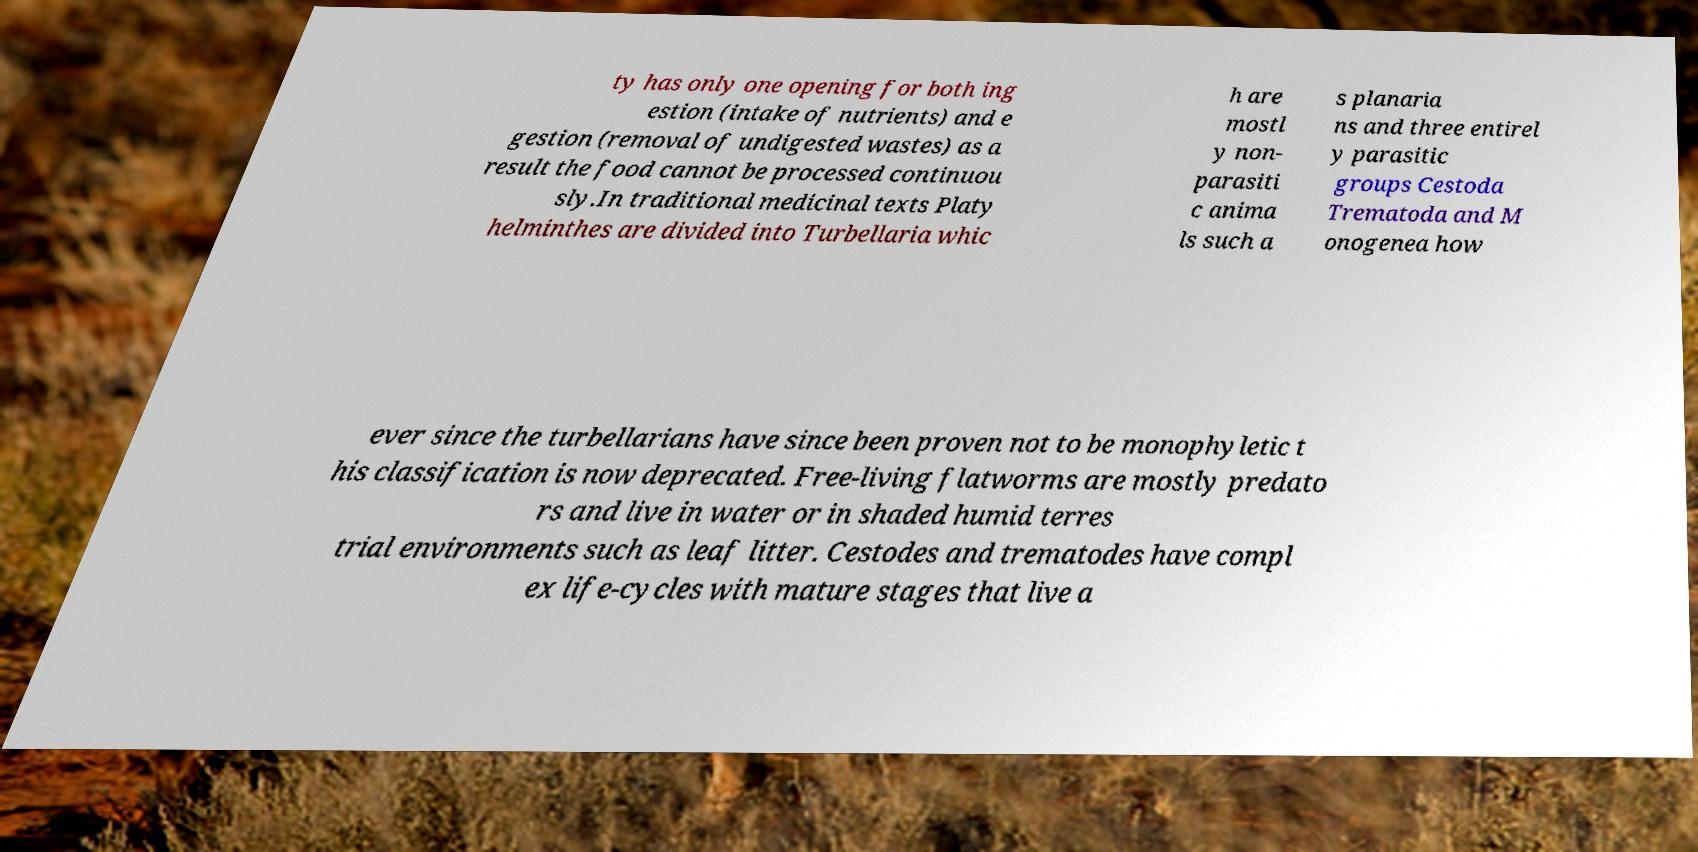Please read and relay the text visible in this image. What does it say? ty has only one opening for both ing estion (intake of nutrients) and e gestion (removal of undigested wastes) as a result the food cannot be processed continuou sly.In traditional medicinal texts Platy helminthes are divided into Turbellaria whic h are mostl y non- parasiti c anima ls such a s planaria ns and three entirel y parasitic groups Cestoda Trematoda and M onogenea how ever since the turbellarians have since been proven not to be monophyletic t his classification is now deprecated. Free-living flatworms are mostly predato rs and live in water or in shaded humid terres trial environments such as leaf litter. Cestodes and trematodes have compl ex life-cycles with mature stages that live a 